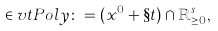<formula> <loc_0><loc_0><loc_500><loc_500>\in v t P o l y \colon = ( x ^ { 0 } + \S t ) \cap \mathbb { R } ^ { s } _ { \geq 0 } ,</formula> 